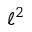Convert formula to latex. <formula><loc_0><loc_0><loc_500><loc_500>\ell ^ { 2 }</formula> 